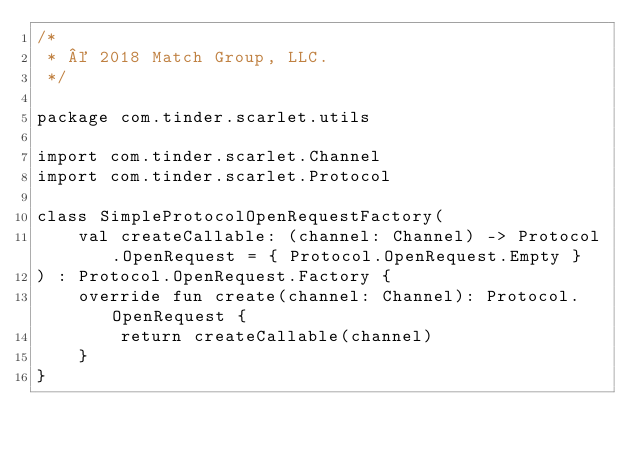Convert code to text. <code><loc_0><loc_0><loc_500><loc_500><_Kotlin_>/*
 * © 2018 Match Group, LLC.
 */

package com.tinder.scarlet.utils

import com.tinder.scarlet.Channel
import com.tinder.scarlet.Protocol

class SimpleProtocolOpenRequestFactory(
    val createCallable: (channel: Channel) -> Protocol.OpenRequest = { Protocol.OpenRequest.Empty }
) : Protocol.OpenRequest.Factory {
    override fun create(channel: Channel): Protocol.OpenRequest {
        return createCallable(channel)
    }
}</code> 